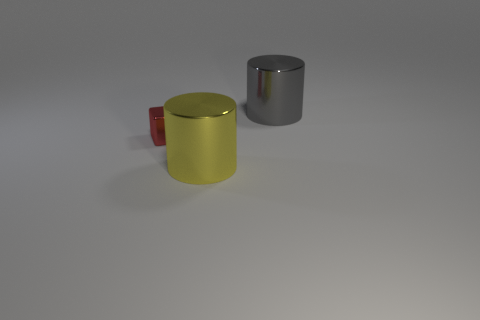Can you describe the textures of the objects in the picture? Certainly! The yellow and gray cylinders have a smooth and reflective surface that appears metallic, suggesting they may be made of metal. The red block looks matte and less reflective, which could possibly be a painted wood or a plastic material. 